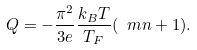Convert formula to latex. <formula><loc_0><loc_0><loc_500><loc_500>Q = - \frac { \pi ^ { 2 } } { 3 e } \frac { k _ { B } T } { T _ { F } } ( \ m n + 1 ) .</formula> 